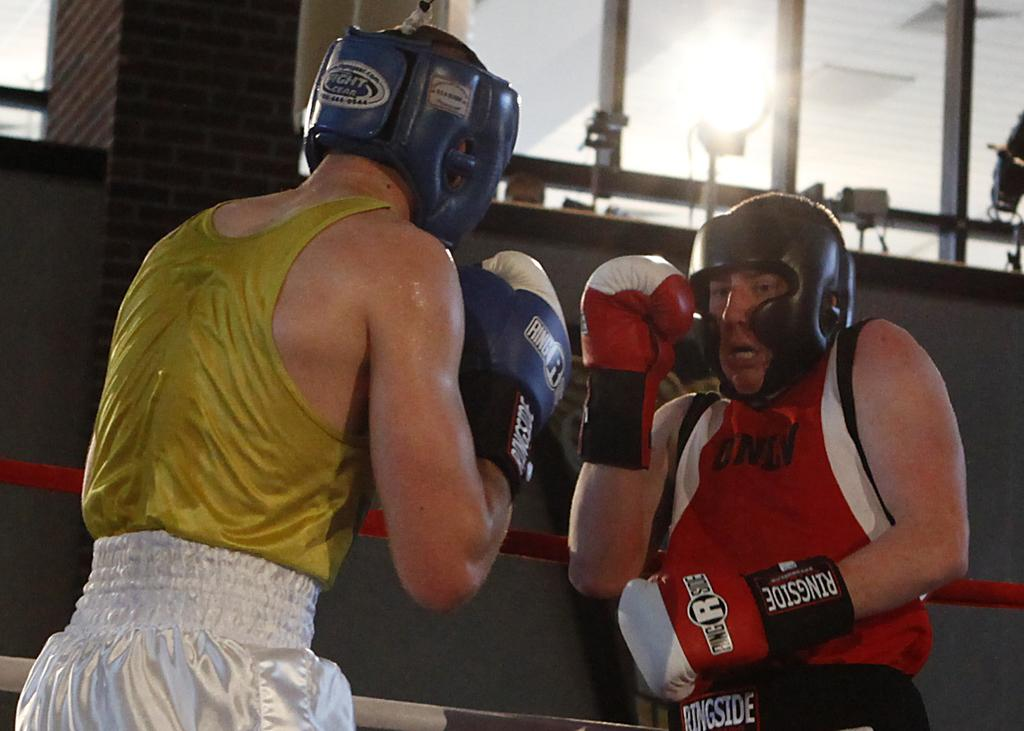<image>
Offer a succinct explanation of the picture presented. The two boxers are wearing Ringside boxing gloves as they fight. 